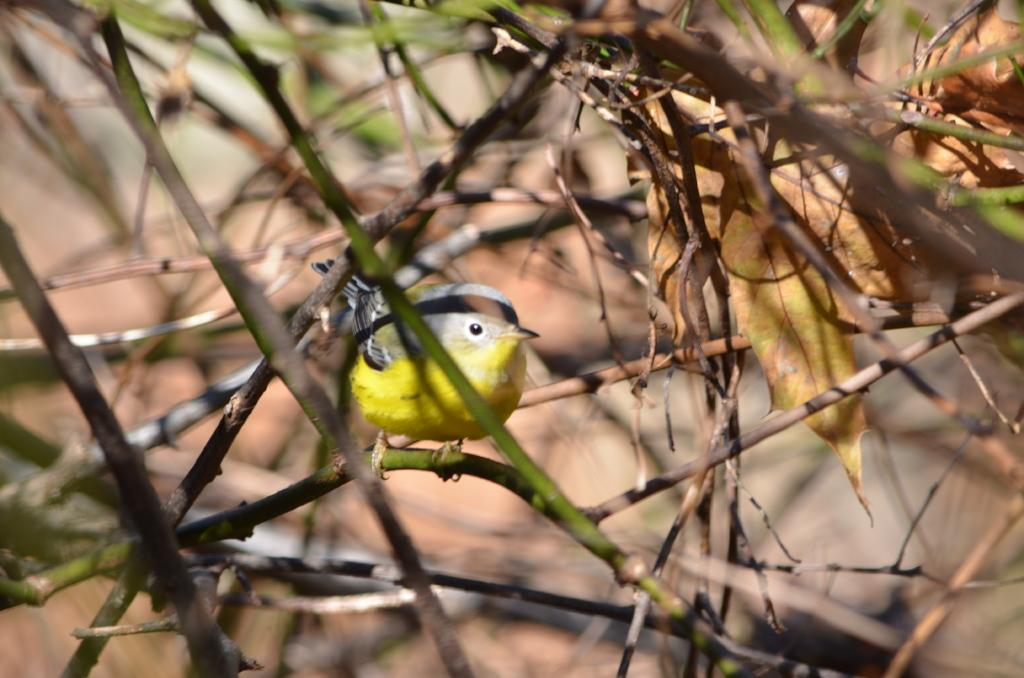What objects can be seen in the image? There are sticks and leaves in the image. What type of animal is present in the image? There is a bird in the image. What color is the bird in the image? The bird is colored yellow. What type of spoon is being used by the bird in the image? There is no spoon present in the image; it features sticks, leaves, and a yellow bird. Who is the manager of the bird in the image? There is no manager mentioned or implied in the image; it simply shows a bird among sticks and leaves. 